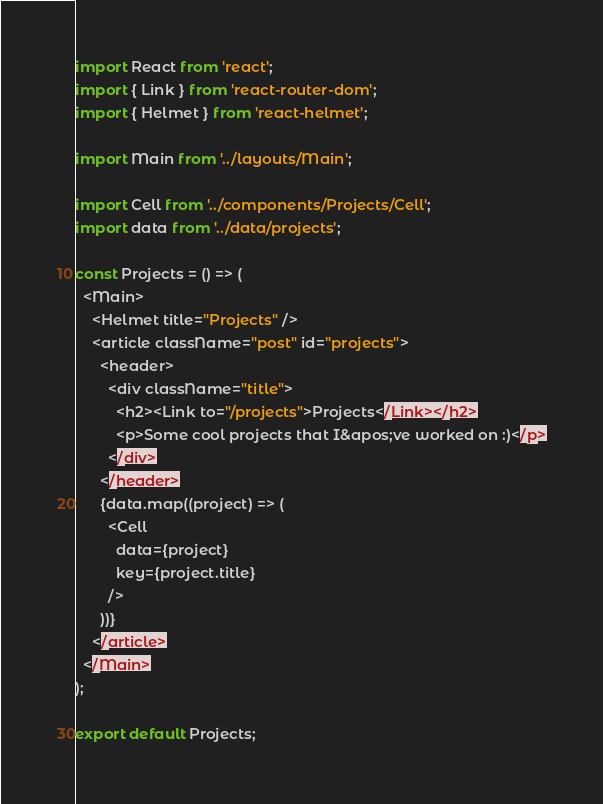Convert code to text. <code><loc_0><loc_0><loc_500><loc_500><_JavaScript_>import React from 'react';
import { Link } from 'react-router-dom';
import { Helmet } from 'react-helmet';

import Main from '../layouts/Main';

import Cell from '../components/Projects/Cell';
import data from '../data/projects';

const Projects = () => (
  <Main>
    <Helmet title="Projects" />
    <article className="post" id="projects">
      <header>
        <div className="title">
          <h2><Link to="/projects">Projects</Link></h2>
          <p>Some cool projects that I&apos;ve worked on :)</p>
        </div>
      </header>
      {data.map((project) => (
        <Cell
          data={project}
          key={project.title}
        />
      ))}
    </article>
  </Main>
);

export default Projects;
</code> 